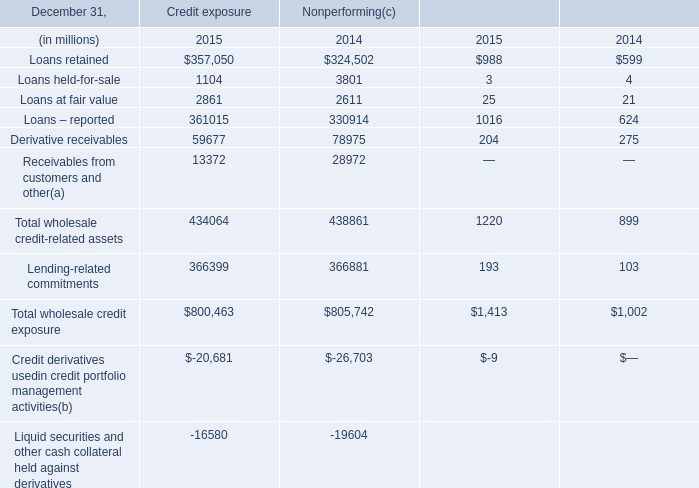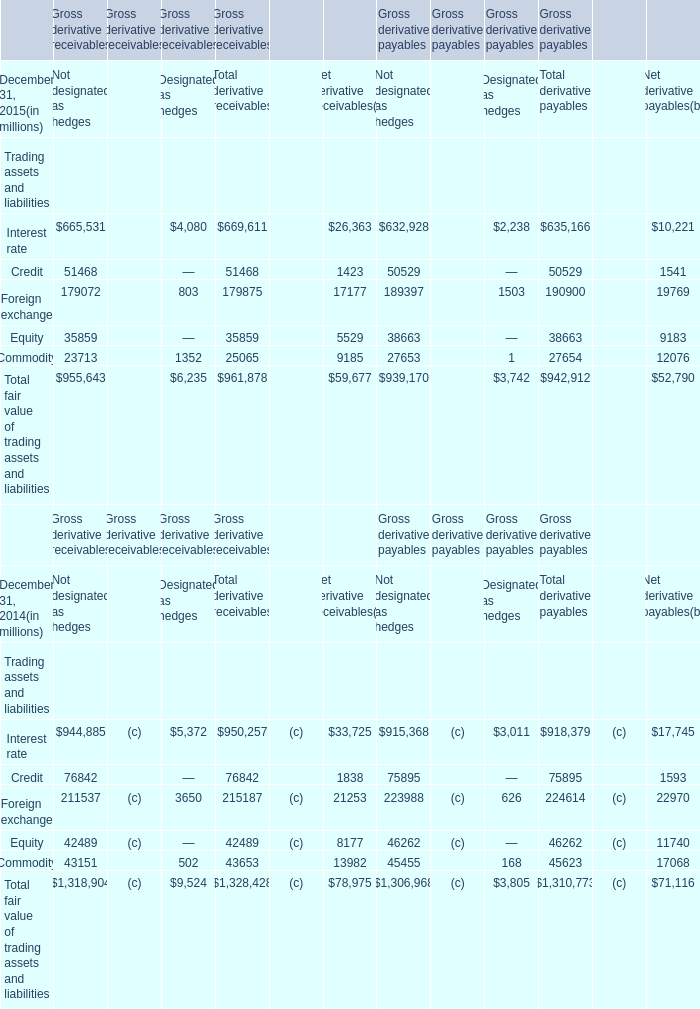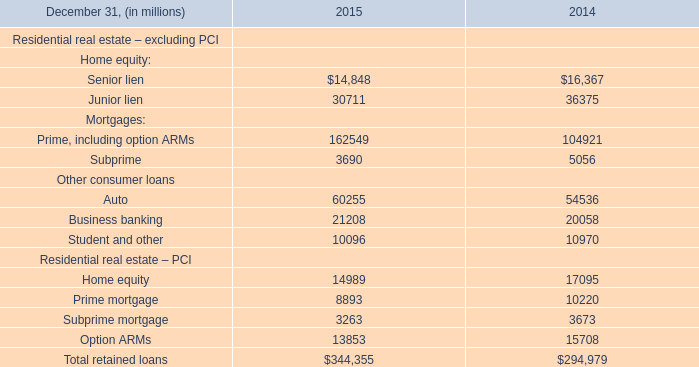What is the average amount of Receivables from customers and other of Nonperforming 2014, and Interest rate of Gross derivative payables Not designated as hedges ? 
Computations: ((28972.0 + 632928.0) / 2)
Answer: 330950.0. 